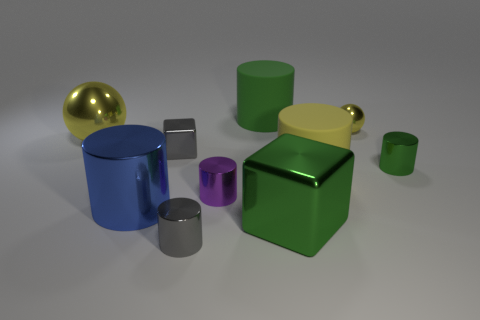Subtract 1 cylinders. How many cylinders are left? 5 Subtract all yellow cylinders. How many cylinders are left? 5 Subtract all small gray cylinders. How many cylinders are left? 5 Subtract all red balls. Subtract all gray blocks. How many balls are left? 2 Subtract all cubes. How many objects are left? 8 Subtract all tiny cyan objects. Subtract all yellow metallic spheres. How many objects are left? 8 Add 2 small green things. How many small green things are left? 3 Add 9 small cubes. How many small cubes exist? 10 Subtract 0 blue spheres. How many objects are left? 10 